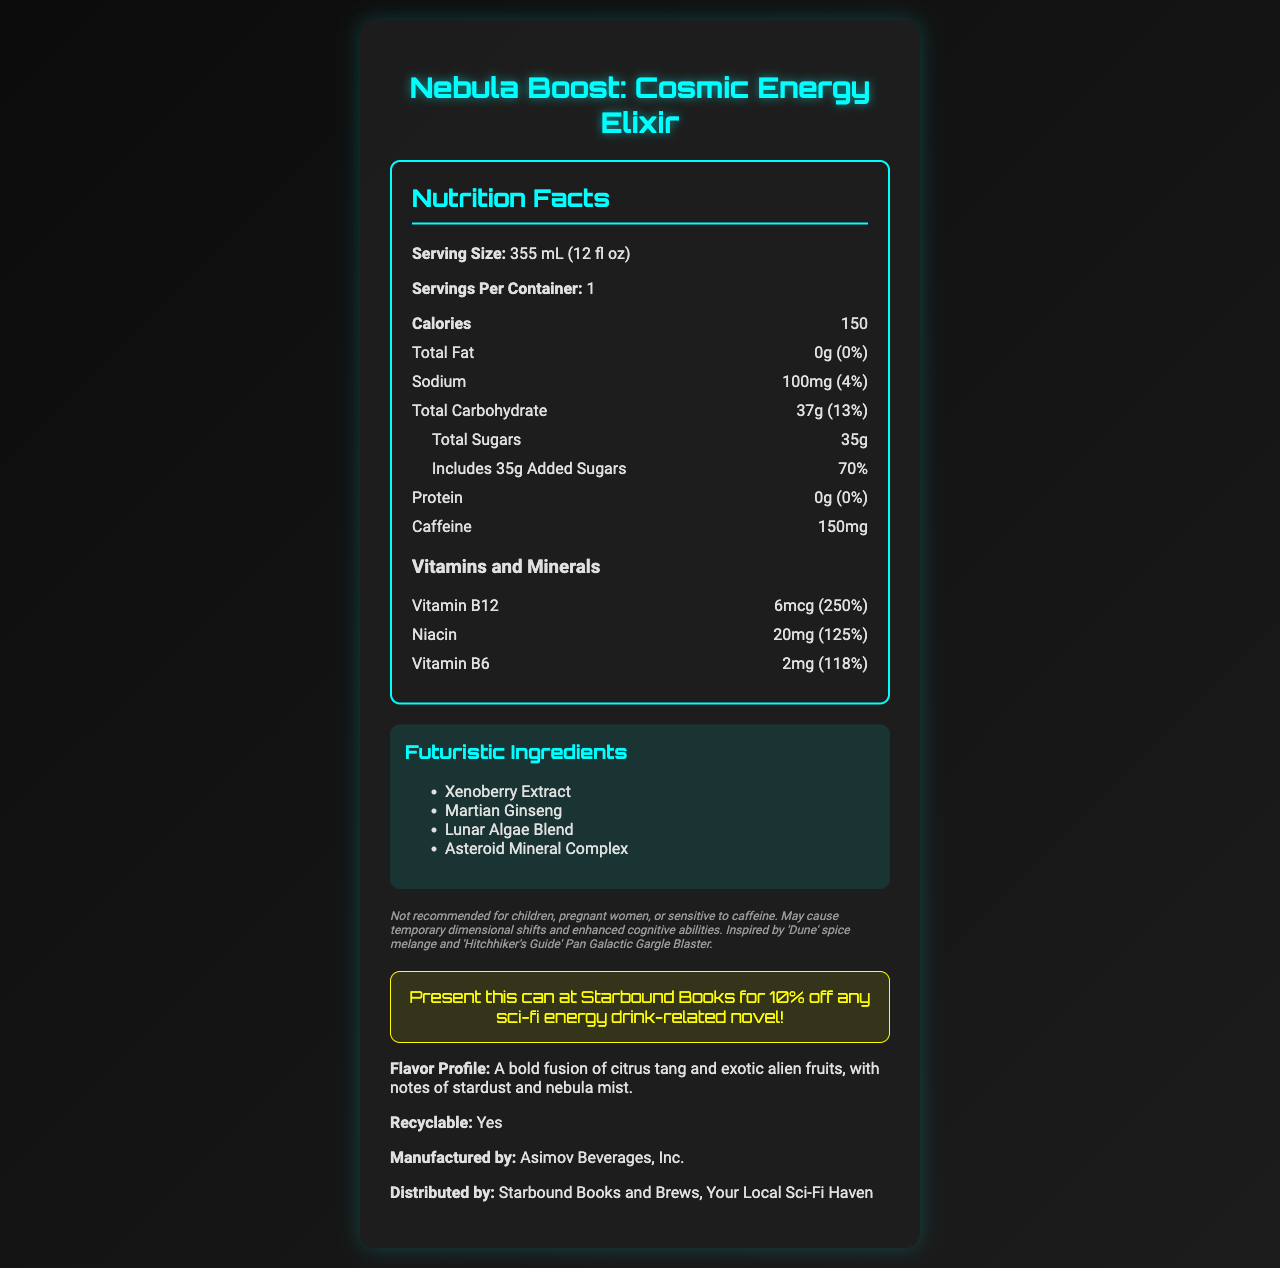what is the serving size of the Nebula Boost: Cosmic Energy Elixir? The serving size is clearly listed as "355 mL (12 fl oz)".
Answer: 355 mL (12 fl oz) how many calories are in one serving of this energy drink? The document states that there are 150 calories per serving.
Answer: 150 how much sodium does the drink contain? The sodium content is stated as "100mg".
Answer: 100mg what is the daily value percentage of Vitamin B12? The document clearly lists the daily value percentage for Vitamin B12 as "250%".
Answer: 250% what are the futuristic ingredients in the Nebula Boost: Cosmic Energy Elixir? The futuristic ingredients are listed under the "Futuristic Ingredients" section.
Answer: Xenoberry Extract, Martian Ginseng, Lunar Algae Blend, Asteroid Mineral Complex what is the caffeine content in the drink? The caffeine content is listed as "150mg".
Answer: 150mg which of the following vitamins has the highest daily value percentage in the drink?
A. Vitamin B12
B. Niacin
C. Vitamin B6 Vitamin B12 has the highest daily value percentage at 250%, compared to Niacin at 125% and Vitamin B6 at 118%.
Answer: A. Vitamin B12 what percentage of daily value does the total carbohydrate content contribute? The total carbohydrate content contributes 13% to the daily value.
Answer: 13% how many servings are in one container of the drink? The document states there is 1 serving per container.
Answer: 1 true or false: The drink contains total sugars amounting to 35g. The document mentions a total of 35g in sugars.
Answer: True which statement is NOT mentioned in the disclaimer?
A. Not recommended for children
B. May cause temporary dimensional shifts
C. Contains gluten
D. Inspired by 'Dune' spice melange The disclaimer does not mention anything about gluten content.
Answer: C. Contains gluten what is the promotion associated with this energy drink? The promotion is highlighted as presenting the can at Starbound Books to get 10% off any sci-fi energy drink-related novel.
Answer: Present this can at Starbound Books for 10% off any sci-fi energy drink-related novel! describe the flavor profile of the Nebula Boost: Cosmic Energy Elixir. The flavor profile is described in the document as "A bold fusion of citrus tang and exotic alien fruits, with notes of stardust and nebula mist".
Answer: A bold fusion of citrus tang and exotic alien fruits, with notes of stardust and nebula mist what company manufactures the Nebula Boost: Cosmic Energy Elixir? The manufacturing company is listed as "Asimov Beverages, Inc."
Answer: Asimov Beverages, Inc. is the Nebula Boost: Cosmic Energy Elixir recyclable? The document states that the product is recyclable.
Answer: Yes who distributes the Nebula Boost: Cosmic Energy Elixir? The document mentions it is distributed by "Starbound Books and Brews, Your Local Sci-Fi Haven."
Answer: Starbound Books and Brews, Your Local Sci-Fi Haven summarize the main idea of the document. The summary includes key points such as the product name, nutritional information, ingredients, caffeine content, promotion, disclaimer, and manufacturing details.
Answer: The document is a Nutrition Facts label for Nebula Boost: Cosmic Energy Elixir, detailing nutritional information, ingredients, caffeine content, vitamins and minerals, and a special promotion for users. It includes a disclaimer about who should not consume it and mentions its futuristic ingredients and flavor profile. Additionally, it provides information about its recyclability, manufacture, and distribution. how many milligrams of caffeine are safe for a pregnant woman to consume daily? The document states the total caffeine content but does not provide information on safe caffeine levels for pregnant women.
Answer: Cannot be determined 